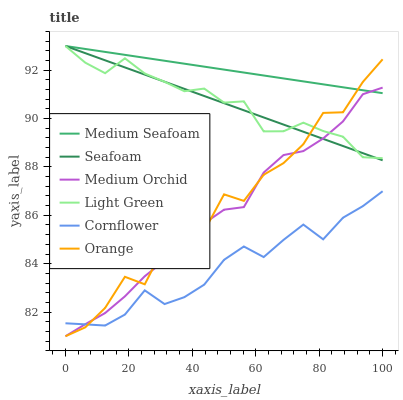Does Cornflower have the minimum area under the curve?
Answer yes or no. Yes. Does Medium Seafoam have the maximum area under the curve?
Answer yes or no. Yes. Does Medium Orchid have the minimum area under the curve?
Answer yes or no. No. Does Medium Orchid have the maximum area under the curve?
Answer yes or no. No. Is Seafoam the smoothest?
Answer yes or no. Yes. Is Orange the roughest?
Answer yes or no. Yes. Is Medium Orchid the smoothest?
Answer yes or no. No. Is Medium Orchid the roughest?
Answer yes or no. No. Does Seafoam have the lowest value?
Answer yes or no. No. Does Medium Seafoam have the highest value?
Answer yes or no. Yes. Does Medium Orchid have the highest value?
Answer yes or no. No. Is Cornflower less than Medium Seafoam?
Answer yes or no. Yes. Is Medium Seafoam greater than Cornflower?
Answer yes or no. Yes. Does Orange intersect Light Green?
Answer yes or no. Yes. Is Orange less than Light Green?
Answer yes or no. No. Is Orange greater than Light Green?
Answer yes or no. No. Does Cornflower intersect Medium Seafoam?
Answer yes or no. No. 